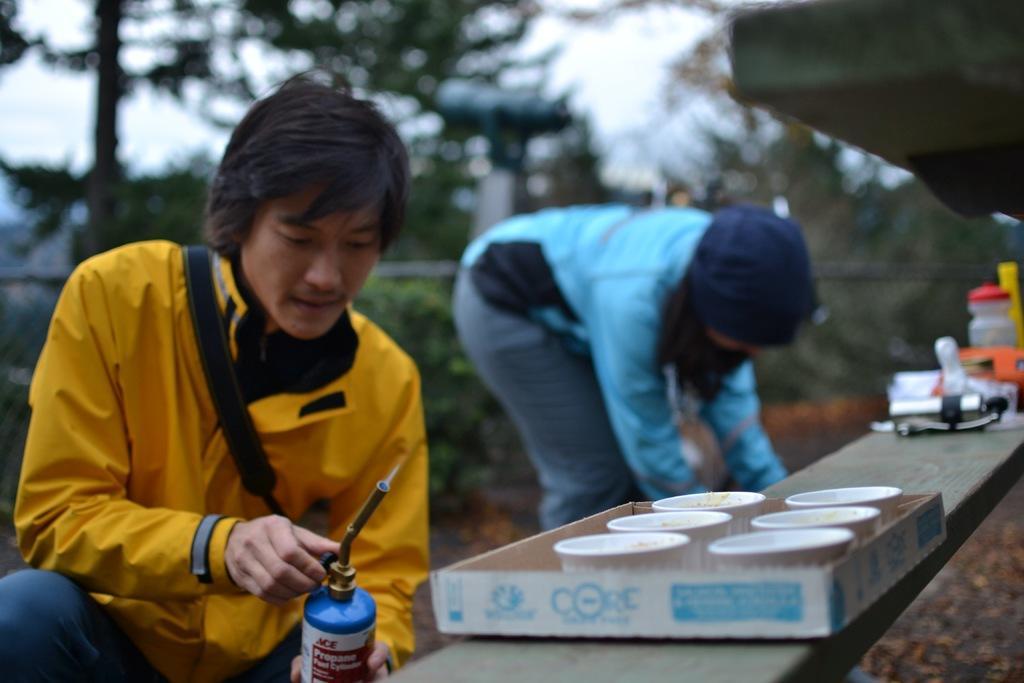Can you describe this image briefly? In this picture we can see two person's, a person in the front is holding a portable gas stove, on the right side there is a box, we can see some cups in the box, we can also see a bottle and some things on the right side, in the background there are trees, we can see a blurry background. 